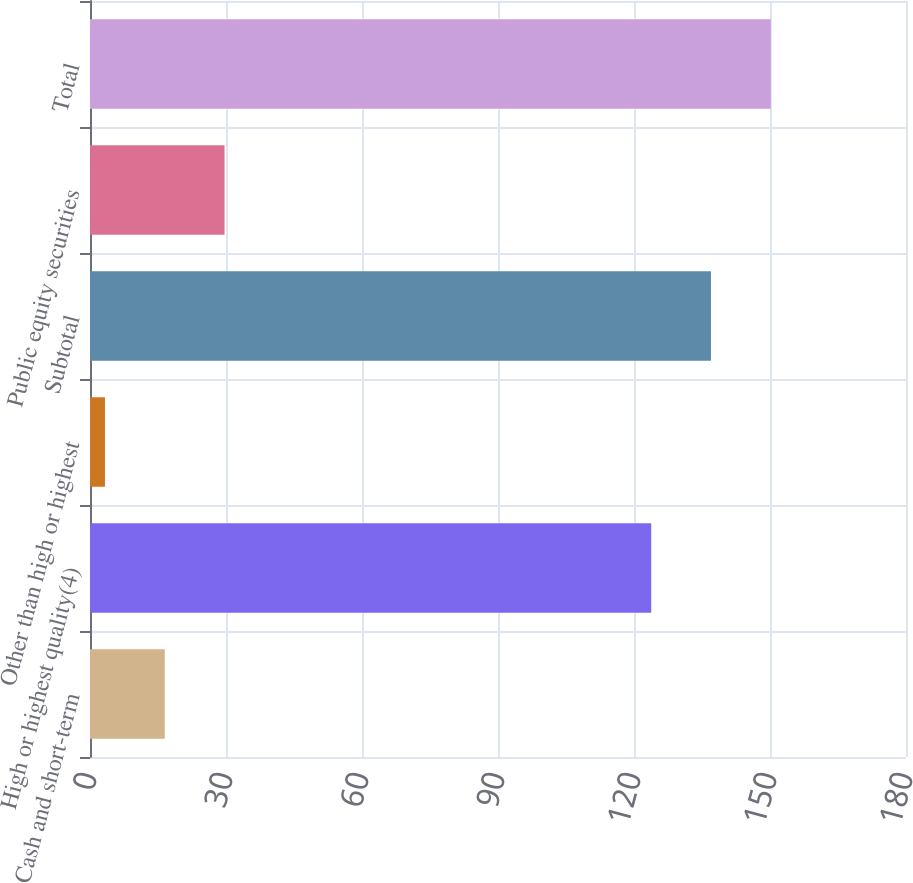<chart> <loc_0><loc_0><loc_500><loc_500><bar_chart><fcel>Cash and short-term<fcel>High or highest quality(4)<fcel>Other than high or highest<fcel>Subtotal<fcel>Public equity securities<fcel>Total<nl><fcel>16.49<fcel>123.8<fcel>3.3<fcel>136.99<fcel>29.68<fcel>150.18<nl></chart> 